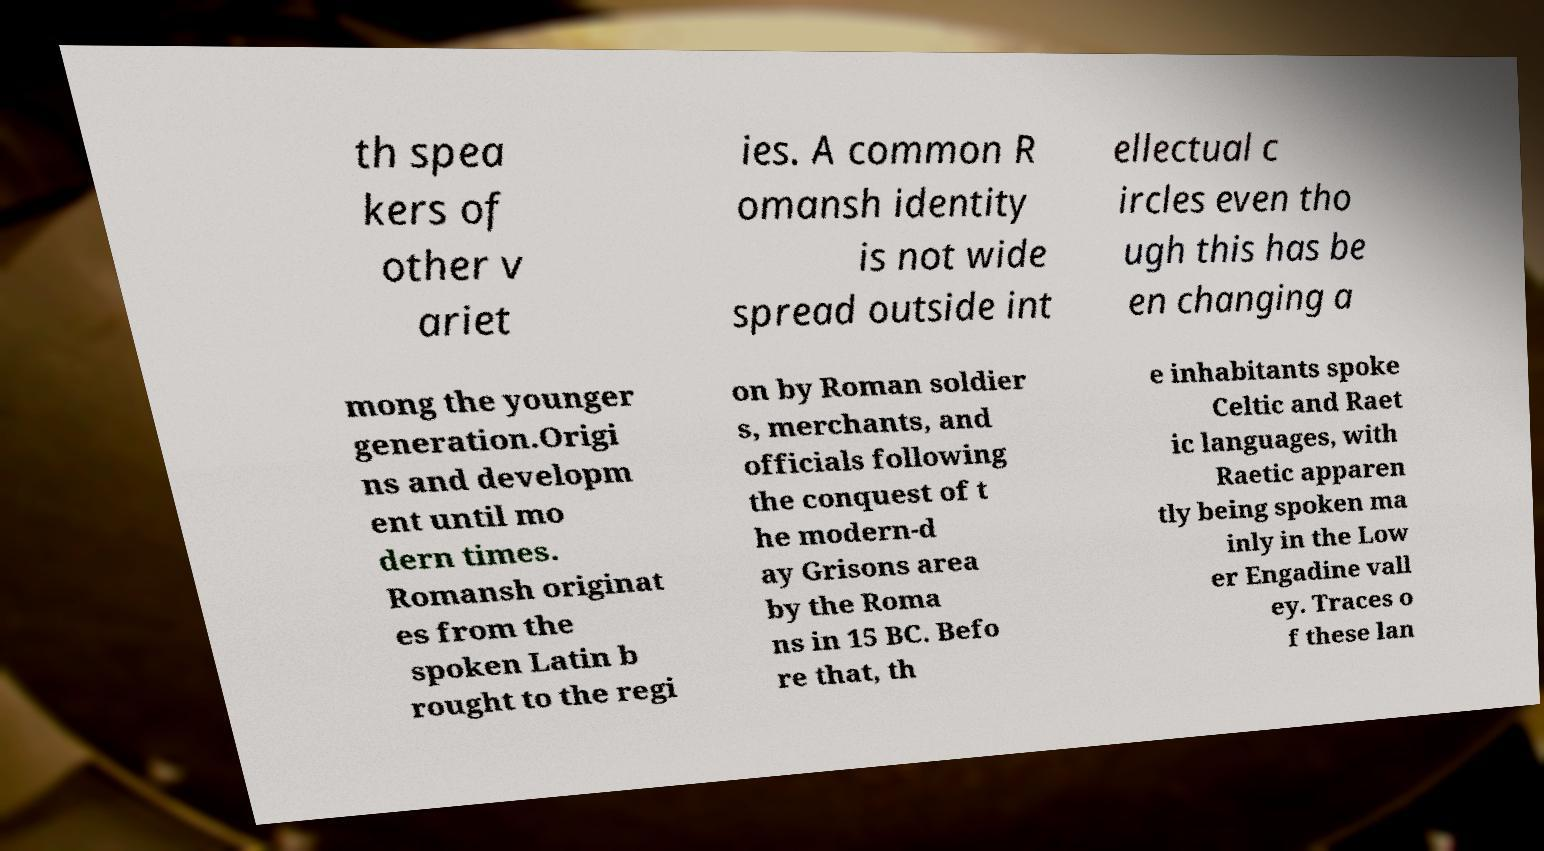There's text embedded in this image that I need extracted. Can you transcribe it verbatim? th spea kers of other v ariet ies. A common R omansh identity is not wide spread outside int ellectual c ircles even tho ugh this has be en changing a mong the younger generation.Origi ns and developm ent until mo dern times. Romansh originat es from the spoken Latin b rought to the regi on by Roman soldier s, merchants, and officials following the conquest of t he modern-d ay Grisons area by the Roma ns in 15 BC. Befo re that, th e inhabitants spoke Celtic and Raet ic languages, with Raetic apparen tly being spoken ma inly in the Low er Engadine vall ey. Traces o f these lan 